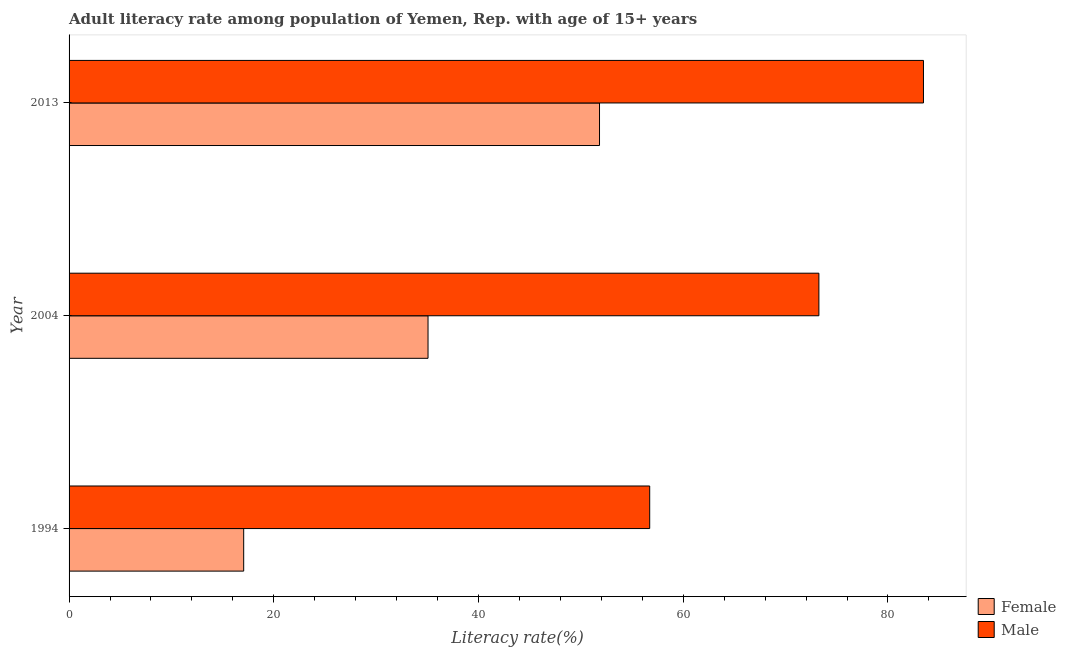How many groups of bars are there?
Your answer should be compact. 3. Are the number of bars per tick equal to the number of legend labels?
Keep it short and to the point. Yes. Are the number of bars on each tick of the Y-axis equal?
Offer a terse response. Yes. How many bars are there on the 3rd tick from the bottom?
Offer a terse response. 2. In how many cases, is the number of bars for a given year not equal to the number of legend labels?
Give a very brief answer. 0. What is the female adult literacy rate in 2013?
Keep it short and to the point. 51.82. Across all years, what is the maximum male adult literacy rate?
Offer a very short reply. 83.47. Across all years, what is the minimum male adult literacy rate?
Offer a terse response. 56.72. What is the total male adult literacy rate in the graph?
Ensure brevity in your answer.  213.45. What is the difference between the male adult literacy rate in 2004 and that in 2013?
Give a very brief answer. -10.22. What is the difference between the female adult literacy rate in 1994 and the male adult literacy rate in 2013?
Provide a short and direct response. -66.41. What is the average male adult literacy rate per year?
Your response must be concise. 71.15. In the year 1994, what is the difference between the male adult literacy rate and female adult literacy rate?
Ensure brevity in your answer.  39.66. In how many years, is the male adult literacy rate greater than 72 %?
Offer a very short reply. 2. What is the ratio of the male adult literacy rate in 1994 to that in 2004?
Your response must be concise. 0.77. Is the male adult literacy rate in 2004 less than that in 2013?
Your answer should be very brief. Yes. Is the difference between the male adult literacy rate in 1994 and 2004 greater than the difference between the female adult literacy rate in 1994 and 2004?
Your answer should be very brief. Yes. What is the difference between the highest and the second highest female adult literacy rate?
Give a very brief answer. 16.75. What is the difference between the highest and the lowest female adult literacy rate?
Ensure brevity in your answer.  34.76. In how many years, is the male adult literacy rate greater than the average male adult literacy rate taken over all years?
Your answer should be compact. 2. Is the sum of the male adult literacy rate in 1994 and 2013 greater than the maximum female adult literacy rate across all years?
Keep it short and to the point. Yes. What does the 1st bar from the top in 2013 represents?
Provide a short and direct response. Male. What does the 1st bar from the bottom in 1994 represents?
Your answer should be compact. Female. How many bars are there?
Your answer should be compact. 6. How many years are there in the graph?
Keep it short and to the point. 3. What is the difference between two consecutive major ticks on the X-axis?
Provide a succinct answer. 20. Are the values on the major ticks of X-axis written in scientific E-notation?
Your response must be concise. No. Does the graph contain grids?
Offer a very short reply. No. How many legend labels are there?
Your answer should be very brief. 2. How are the legend labels stacked?
Your answer should be very brief. Vertical. What is the title of the graph?
Provide a short and direct response. Adult literacy rate among population of Yemen, Rep. with age of 15+ years. Does "Technicians" appear as one of the legend labels in the graph?
Your answer should be very brief. No. What is the label or title of the X-axis?
Ensure brevity in your answer.  Literacy rate(%). What is the label or title of the Y-axis?
Offer a terse response. Year. What is the Literacy rate(%) in Female in 1994?
Offer a very short reply. 17.06. What is the Literacy rate(%) in Male in 1994?
Give a very brief answer. 56.72. What is the Literacy rate(%) of Female in 2004?
Provide a short and direct response. 35.07. What is the Literacy rate(%) of Male in 2004?
Keep it short and to the point. 73.25. What is the Literacy rate(%) in Female in 2013?
Provide a succinct answer. 51.82. What is the Literacy rate(%) in Male in 2013?
Keep it short and to the point. 83.47. Across all years, what is the maximum Literacy rate(%) in Female?
Offer a very short reply. 51.82. Across all years, what is the maximum Literacy rate(%) in Male?
Your answer should be very brief. 83.47. Across all years, what is the minimum Literacy rate(%) in Female?
Your answer should be compact. 17.06. Across all years, what is the minimum Literacy rate(%) of Male?
Your answer should be very brief. 56.72. What is the total Literacy rate(%) in Female in the graph?
Provide a succinct answer. 103.95. What is the total Literacy rate(%) in Male in the graph?
Offer a very short reply. 213.45. What is the difference between the Literacy rate(%) in Female in 1994 and that in 2004?
Your answer should be compact. -18.01. What is the difference between the Literacy rate(%) in Male in 1994 and that in 2004?
Your response must be concise. -16.53. What is the difference between the Literacy rate(%) in Female in 1994 and that in 2013?
Your response must be concise. -34.76. What is the difference between the Literacy rate(%) of Male in 1994 and that in 2013?
Provide a succinct answer. -26.75. What is the difference between the Literacy rate(%) of Female in 2004 and that in 2013?
Provide a succinct answer. -16.75. What is the difference between the Literacy rate(%) in Male in 2004 and that in 2013?
Make the answer very short. -10.22. What is the difference between the Literacy rate(%) of Female in 1994 and the Literacy rate(%) of Male in 2004?
Your answer should be compact. -56.19. What is the difference between the Literacy rate(%) of Female in 1994 and the Literacy rate(%) of Male in 2013?
Your response must be concise. -66.41. What is the difference between the Literacy rate(%) in Female in 2004 and the Literacy rate(%) in Male in 2013?
Provide a short and direct response. -48.4. What is the average Literacy rate(%) in Female per year?
Offer a terse response. 34.65. What is the average Literacy rate(%) of Male per year?
Offer a very short reply. 71.15. In the year 1994, what is the difference between the Literacy rate(%) in Female and Literacy rate(%) in Male?
Offer a terse response. -39.67. In the year 2004, what is the difference between the Literacy rate(%) of Female and Literacy rate(%) of Male?
Provide a short and direct response. -38.18. In the year 2013, what is the difference between the Literacy rate(%) of Female and Literacy rate(%) of Male?
Your answer should be very brief. -31.65. What is the ratio of the Literacy rate(%) in Female in 1994 to that in 2004?
Ensure brevity in your answer.  0.49. What is the ratio of the Literacy rate(%) in Male in 1994 to that in 2004?
Offer a terse response. 0.77. What is the ratio of the Literacy rate(%) of Female in 1994 to that in 2013?
Your answer should be compact. 0.33. What is the ratio of the Literacy rate(%) in Male in 1994 to that in 2013?
Keep it short and to the point. 0.68. What is the ratio of the Literacy rate(%) of Female in 2004 to that in 2013?
Offer a very short reply. 0.68. What is the ratio of the Literacy rate(%) of Male in 2004 to that in 2013?
Offer a very short reply. 0.88. What is the difference between the highest and the second highest Literacy rate(%) of Female?
Give a very brief answer. 16.75. What is the difference between the highest and the second highest Literacy rate(%) of Male?
Offer a terse response. 10.22. What is the difference between the highest and the lowest Literacy rate(%) in Female?
Give a very brief answer. 34.76. What is the difference between the highest and the lowest Literacy rate(%) of Male?
Your response must be concise. 26.75. 